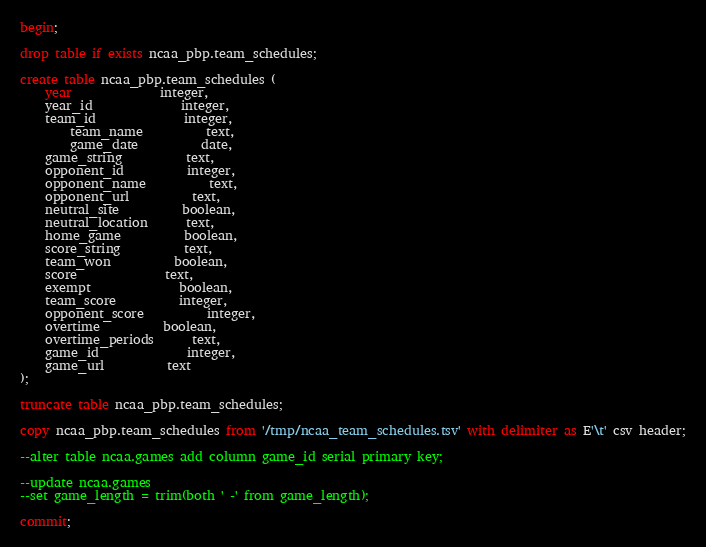Convert code to text. <code><loc_0><loc_0><loc_500><loc_500><_SQL_>begin;

drop table if exists ncaa_pbp.team_schedules;

create table ncaa_pbp.team_schedules (
	year		      integer,
	year_id		      integer,
	team_id		      integer,
        team_name	      text,
        game_date	      date,
	game_string	      text,
	opponent_id	      integer,
	opponent_name	      text,
	opponent_url	      text,
	neutral_site	      boolean,
	neutral_location      text,
	home_game	      boolean,
	score_string	      text,
	team_won	      boolean,
	score		      text,
	exempt		      boolean,
	team_score	      integer,
	opponent_score	      integer,
	overtime	      boolean,
	overtime_periods      text,
	game_id		      integer,
	game_url	      text
);

truncate table ncaa_pbp.team_schedules;

copy ncaa_pbp.team_schedules from '/tmp/ncaa_team_schedules.tsv' with delimiter as E'\t' csv header;

--alter table ncaa.games add column game_id serial primary key;

--update ncaa.games
--set game_length = trim(both ' -' from game_length);

commit;
</code> 